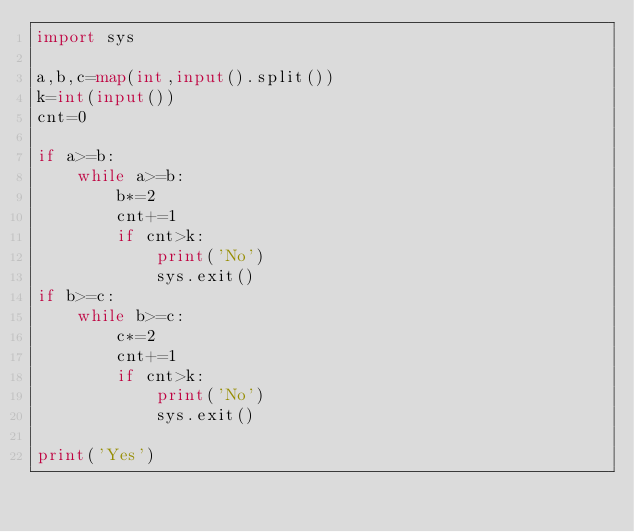Convert code to text. <code><loc_0><loc_0><loc_500><loc_500><_Python_>import sys

a,b,c=map(int,input().split())
k=int(input())
cnt=0

if a>=b:
    while a>=b:
        b*=2
        cnt+=1
        if cnt>k:
            print('No')
            sys.exit()
if b>=c:
    while b>=c:
        c*=2
        cnt+=1
        if cnt>k:
            print('No')
            sys.exit()
            
print('Yes')</code> 